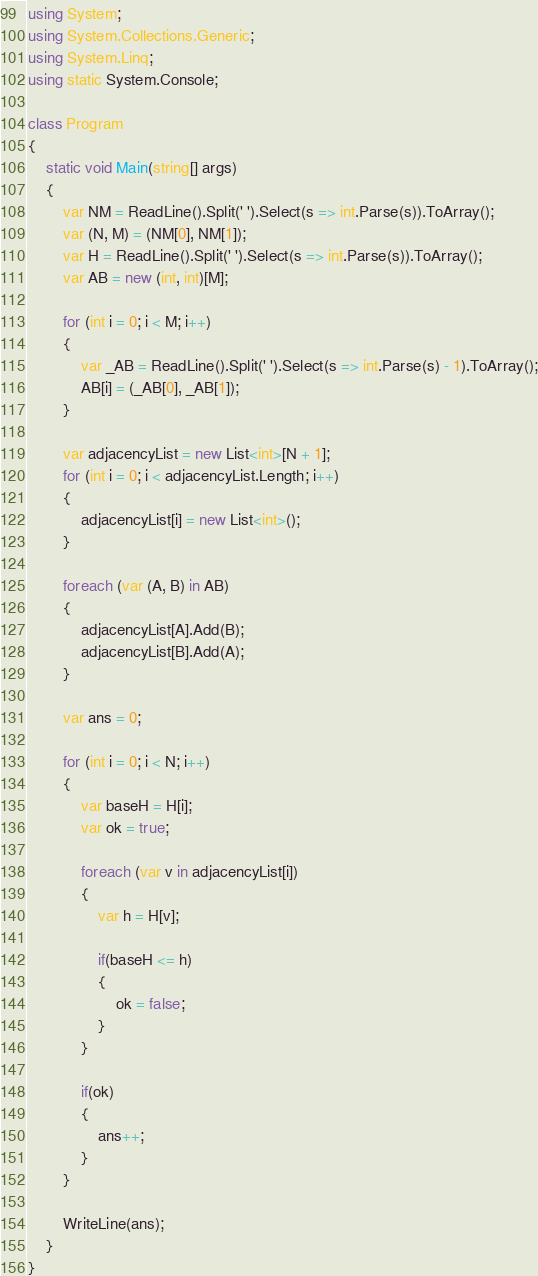Convert code to text. <code><loc_0><loc_0><loc_500><loc_500><_C#_>using System;
using System.Collections.Generic;
using System.Linq;
using static System.Console;

class Program
{
    static void Main(string[] args)
    {
        var NM = ReadLine().Split(' ').Select(s => int.Parse(s)).ToArray();
        var (N, M) = (NM[0], NM[1]);
        var H = ReadLine().Split(' ').Select(s => int.Parse(s)).ToArray();
        var AB = new (int, int)[M];

        for (int i = 0; i < M; i++)
        {
            var _AB = ReadLine().Split(' ').Select(s => int.Parse(s) - 1).ToArray();
            AB[i] = (_AB[0], _AB[1]);
        }

        var adjacencyList = new List<int>[N + 1];
        for (int i = 0; i < adjacencyList.Length; i++)
        {
            adjacencyList[i] = new List<int>();
        }

        foreach (var (A, B) in AB)
        {
            adjacencyList[A].Add(B);
            adjacencyList[B].Add(A);
        }

        var ans = 0;

        for (int i = 0; i < N; i++)
        {
            var baseH = H[i];
            var ok = true;

            foreach (var v in adjacencyList[i])
            {
                var h = H[v];

                if(baseH <= h)
                {
                    ok = false;
                }
            }

            if(ok)
            {
                ans++;
            }
        }

        WriteLine(ans);
    }
}
</code> 